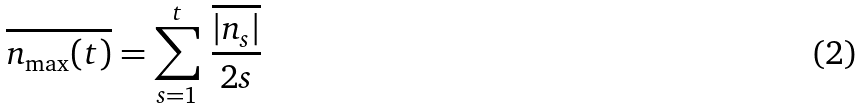Convert formula to latex. <formula><loc_0><loc_0><loc_500><loc_500>\overline { n _ { \max } ( t ) } = \sum ^ { t } _ { s = 1 } \, \frac { \overline { | n _ { s } | } } { 2 s }</formula> 